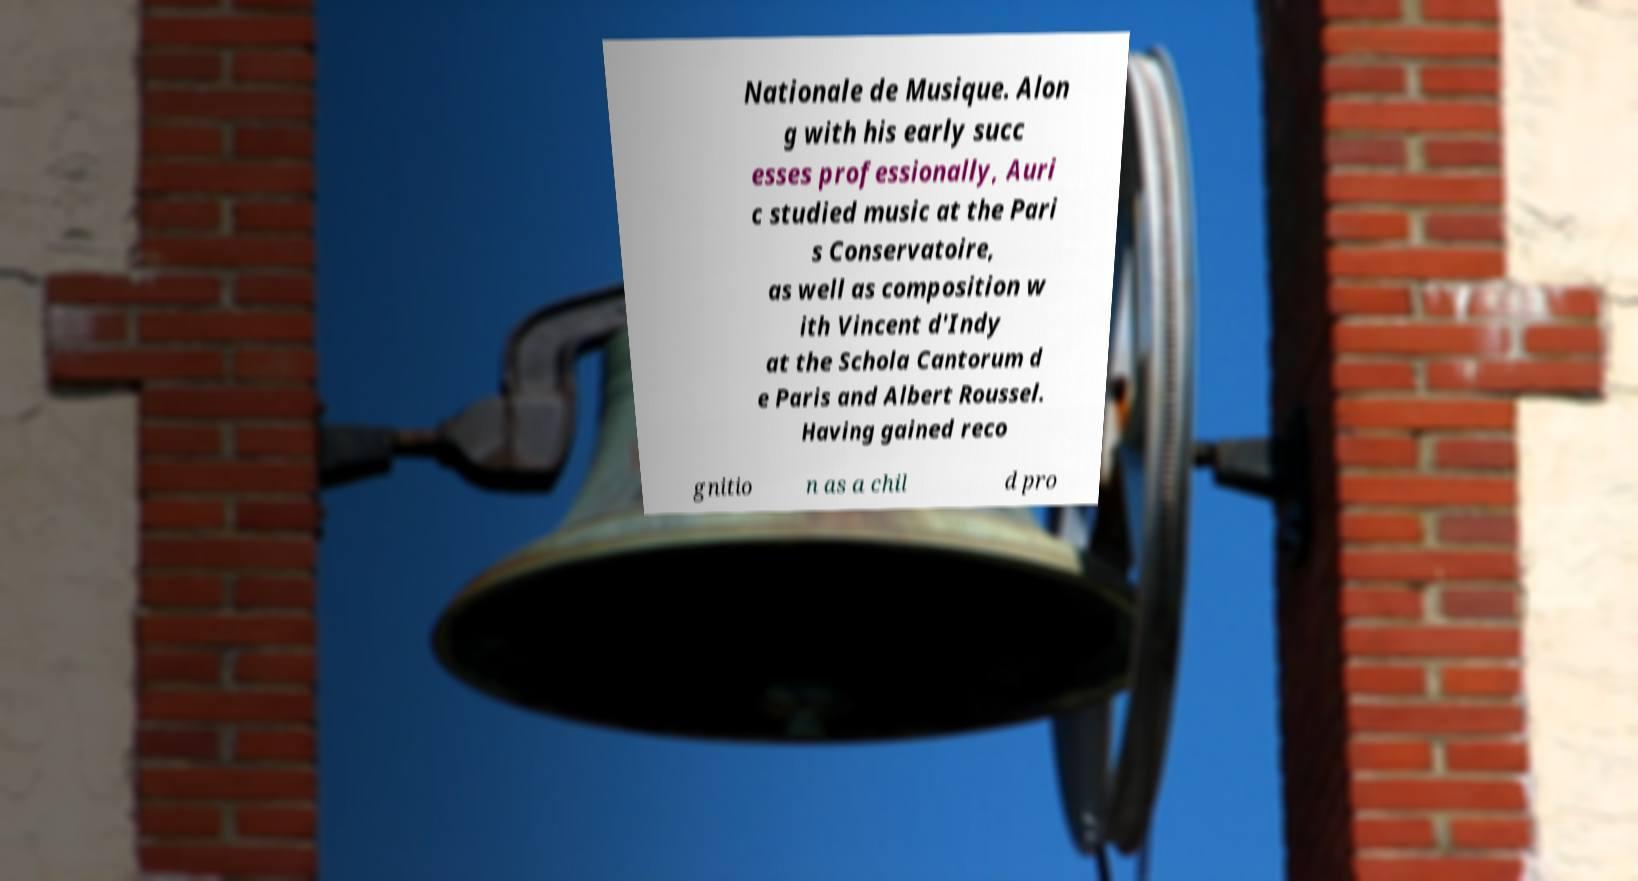There's text embedded in this image that I need extracted. Can you transcribe it verbatim? Nationale de Musique. Alon g with his early succ esses professionally, Auri c studied music at the Pari s Conservatoire, as well as composition w ith Vincent d'Indy at the Schola Cantorum d e Paris and Albert Roussel. Having gained reco gnitio n as a chil d pro 